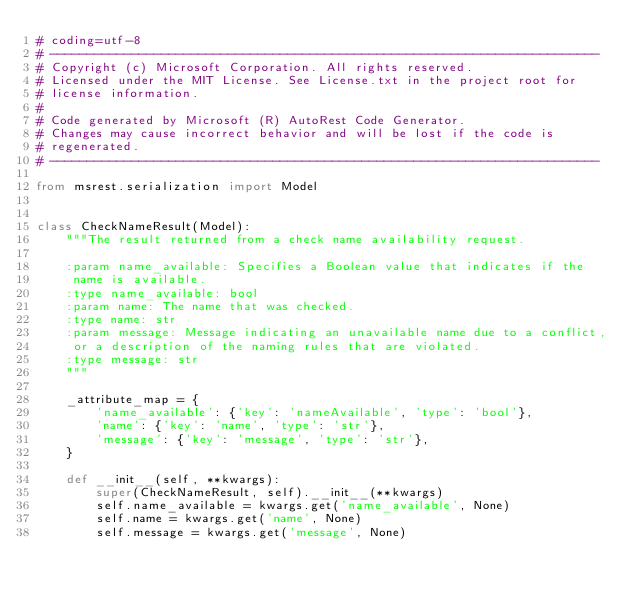Convert code to text. <code><loc_0><loc_0><loc_500><loc_500><_Python_># coding=utf-8
# --------------------------------------------------------------------------
# Copyright (c) Microsoft Corporation. All rights reserved.
# Licensed under the MIT License. See License.txt in the project root for
# license information.
#
# Code generated by Microsoft (R) AutoRest Code Generator.
# Changes may cause incorrect behavior and will be lost if the code is
# regenerated.
# --------------------------------------------------------------------------

from msrest.serialization import Model


class CheckNameResult(Model):
    """The result returned from a check name availability request.

    :param name_available: Specifies a Boolean value that indicates if the
     name is available.
    :type name_available: bool
    :param name: The name that was checked.
    :type name: str
    :param message: Message indicating an unavailable name due to a conflict,
     or a description of the naming rules that are violated.
    :type message: str
    """

    _attribute_map = {
        'name_available': {'key': 'nameAvailable', 'type': 'bool'},
        'name': {'key': 'name', 'type': 'str'},
        'message': {'key': 'message', 'type': 'str'},
    }

    def __init__(self, **kwargs):
        super(CheckNameResult, self).__init__(**kwargs)
        self.name_available = kwargs.get('name_available', None)
        self.name = kwargs.get('name', None)
        self.message = kwargs.get('message', None)
</code> 